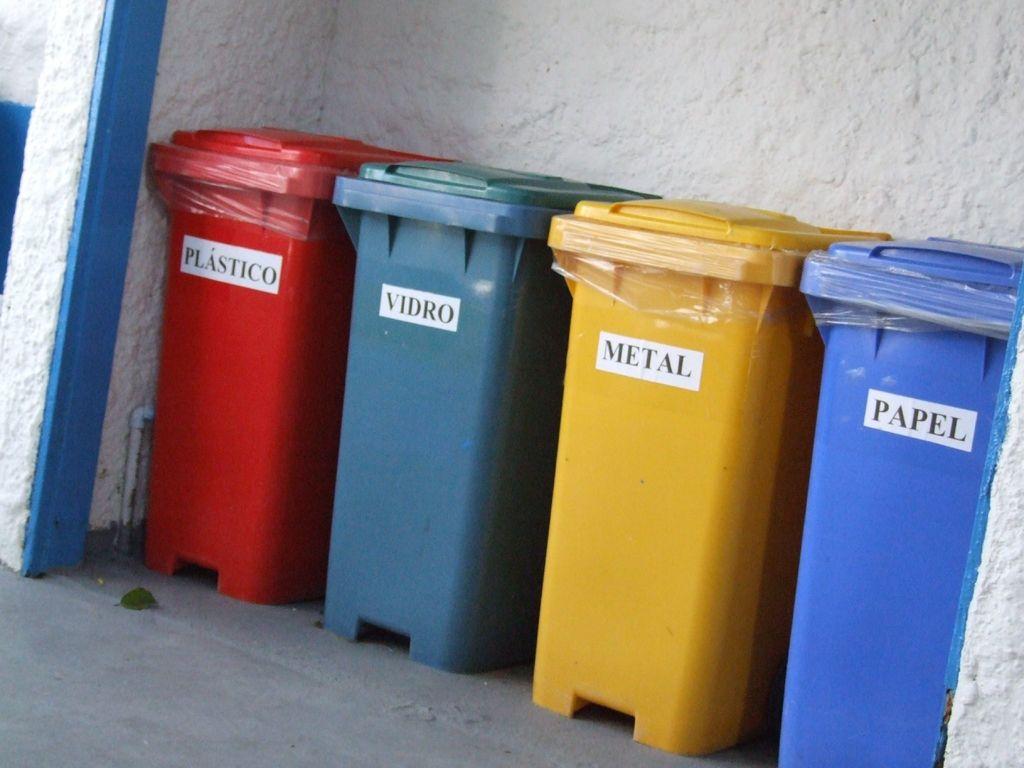Which trashcan is for metal?
Your response must be concise. Yellow. 